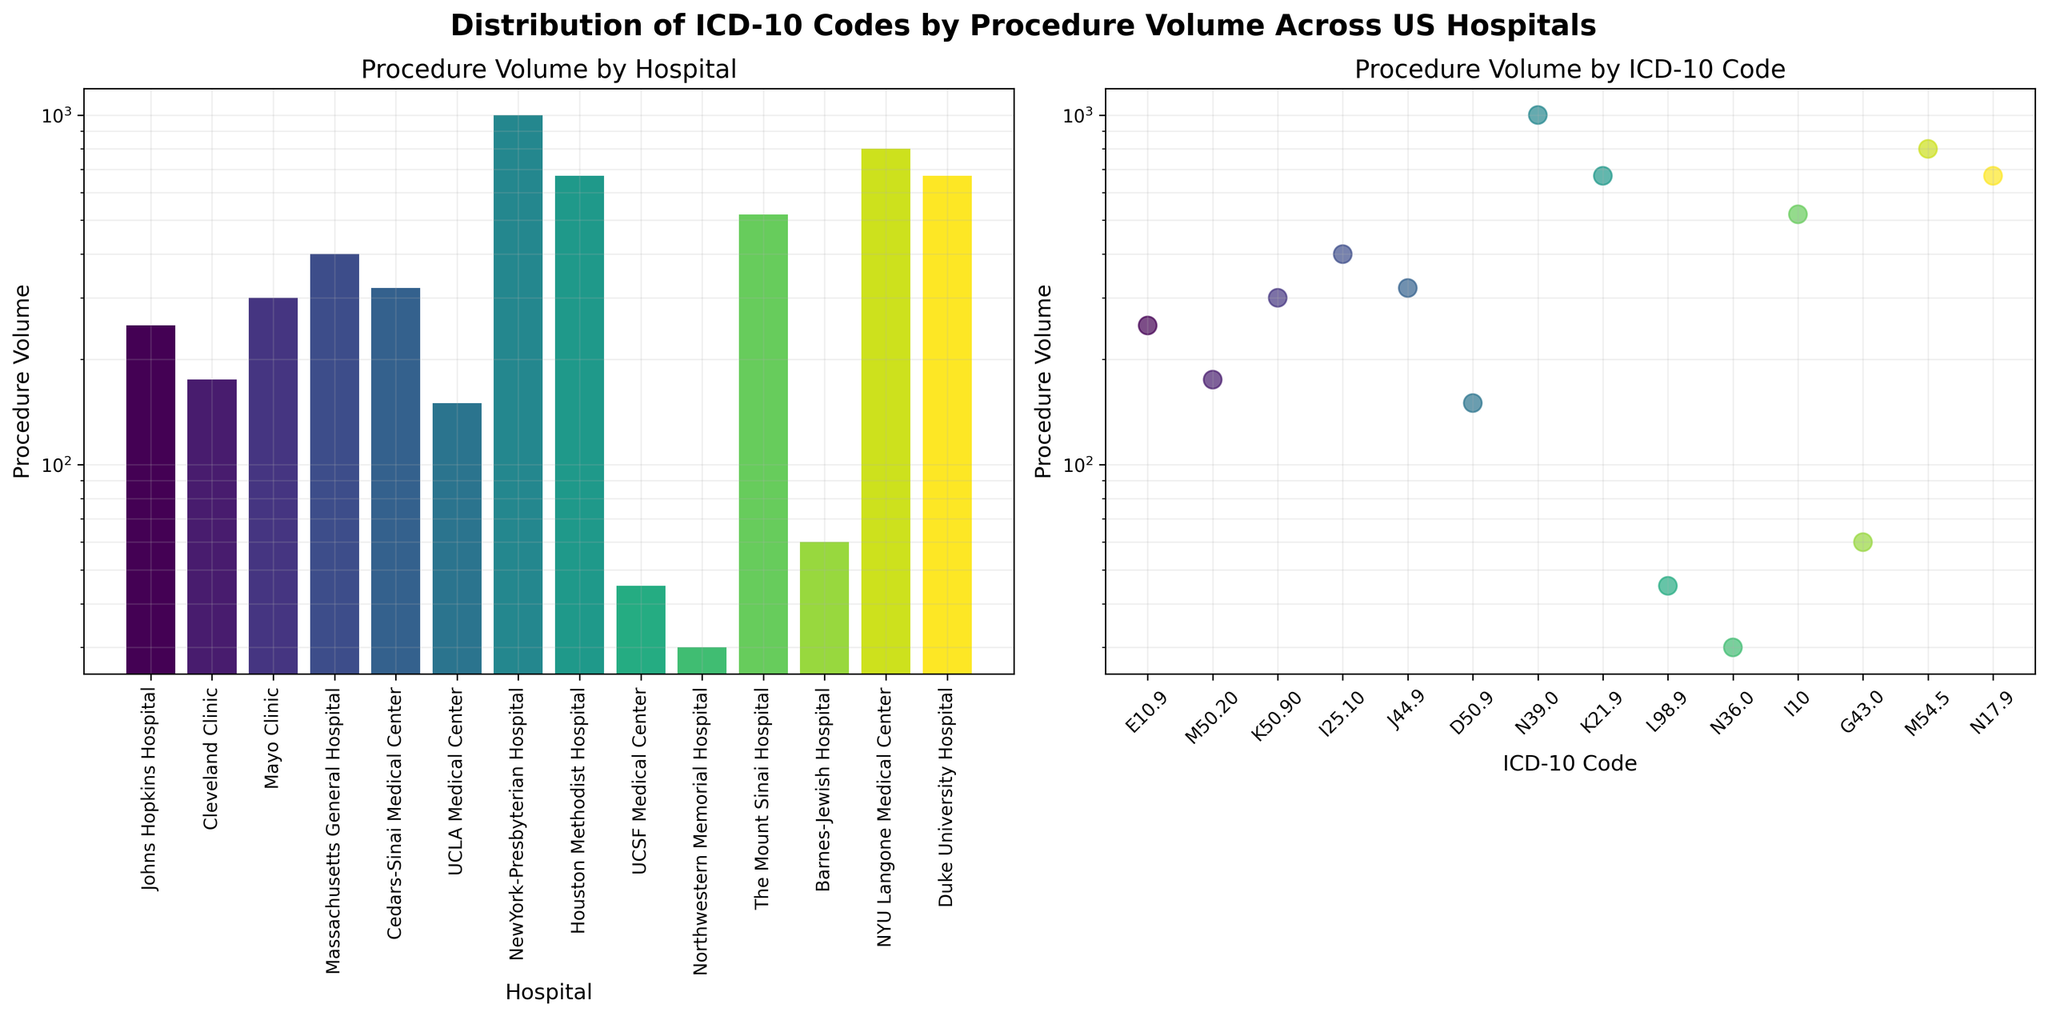What's the title of the entire figure? The title of the entire figure is located at the top center and reads "Distribution of ICD-10 Codes by Procedure Volume Across US Hospitals."
Answer: Distribution of ICD-10 Codes by Procedure Volume Across US Hospitals Which hospital has the highest procedure volume? By comparing the height of the bars in the first subplot, the tallest bar corresponds to "NewYork-Presbyterian Hospital." This means it has the highest procedure volume.
Answer: NewYork-Presbyterian Hospital What is the volume range of the procedure volumes shown in the bar plot? The bar plot uses a log scale, and the y-axis ranges from 10^1 (10) to 10^4 (10,000).
Answer: 10 to 10,000 How many hospitals have procedure volumes below 100? Looking at the bars that fall below the 10^2 (100) line, there are two hospitals: "UCSF Medical Center" and "Northwestern Memorial Hospital."
Answer: 2 hospitals Which ICD-10 code is associated with the lowest procedure volume? In the scatter plot, the lowest point corresponds to the ICD-10 code "N36.0" (Urethral stricture).
Answer: N36.0 What is the most common procedure volume range among hospitals? By examining the distribution of bars in the bar plot, the most frequently occurring volumes fall between 100 and 1,000 (logarithmic scale).
Answer: 100 to 1,000 Compare the procedure volumes of "Cedars-Sinai Medical Center" and "Johns Hopkins Hospital." Which one is higher? In the bar plot, the bar for "Cedars-Sinai Medical Center" (COPD) is lower than the bar for "Johns Hopkins Hospital" (Type 1 diabetes). Therefore, "Johns Hopkins Hospital" has a higher procedure volume.
Answer: Johns Hopkins Hospital What is the procedure volume for the ICD-10 code "J44.9"? From the scatter plot, identify the point associated with "J44.9" (Chronic obstructive pulmonary disease), with the corresponding y-axis value being around 320.
Answer: 320 Which hospital has the smallest procedure volume and what is it? The smallest bar in the bar plot belongs to "Northwestern Memorial Hospital" with a volume of around 30.
Answer: Northwestern Memorial Hospital, 30 What does the y-axis label represent in both subplots? The y-axis label in both the bar plot and scatter plot is "Procedure Volume," representing the number of procedures performed.
Answer: Procedure Volume 